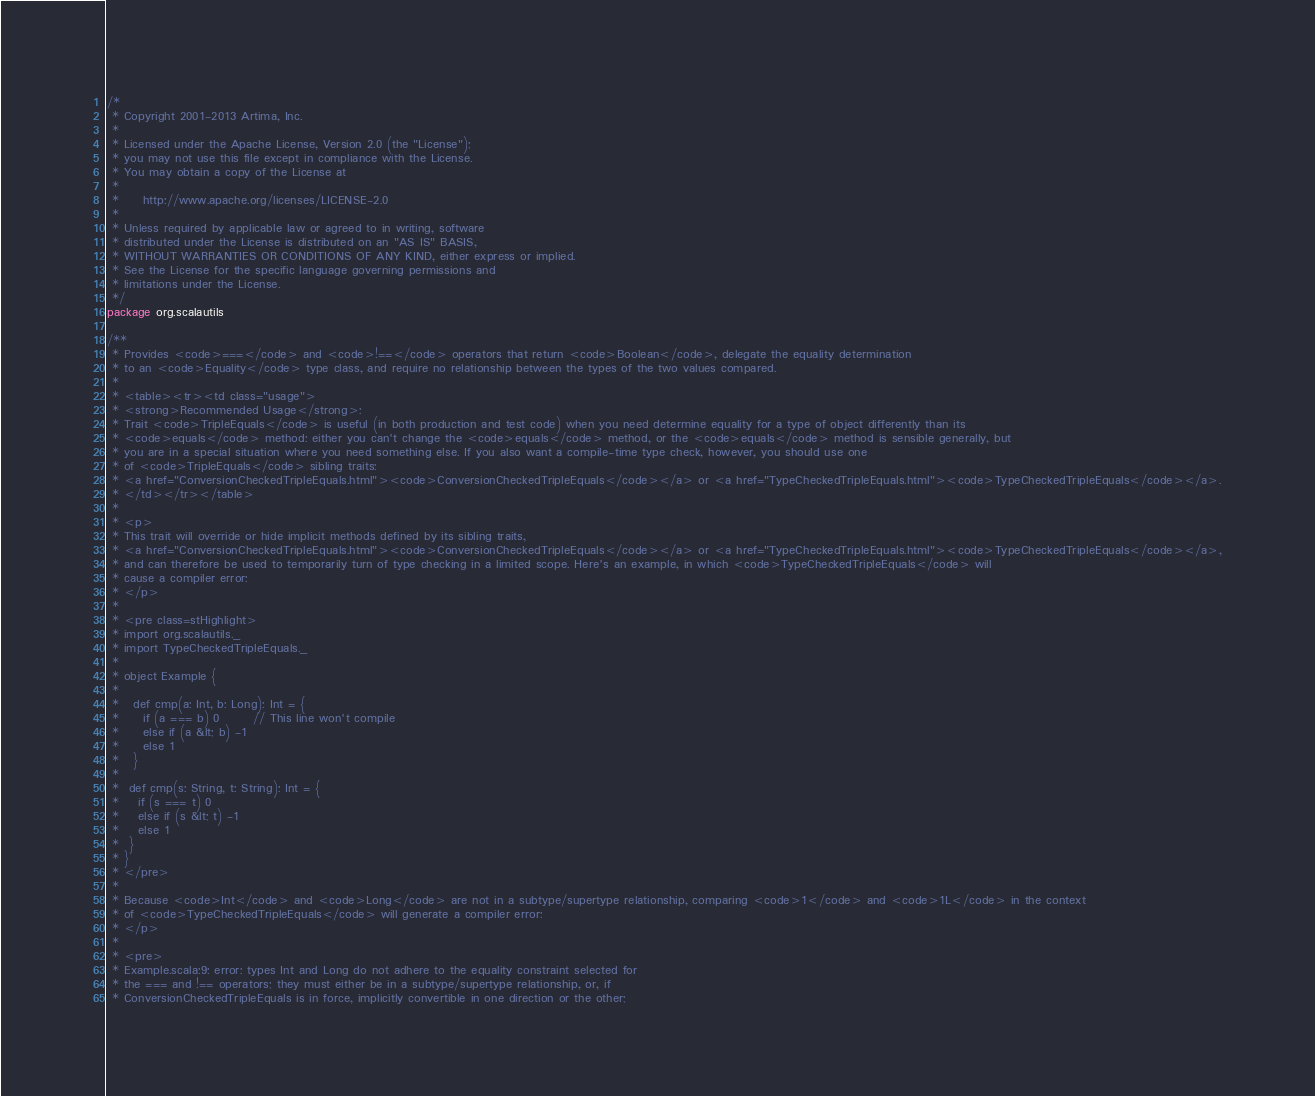Convert code to text. <code><loc_0><loc_0><loc_500><loc_500><_Scala_>/*
 * Copyright 2001-2013 Artima, Inc.
 *
 * Licensed under the Apache License, Version 2.0 (the "License");
 * you may not use this file except in compliance with the License.
 * You may obtain a copy of the License at
 *
 *     http://www.apache.org/licenses/LICENSE-2.0
 *
 * Unless required by applicable law or agreed to in writing, software
 * distributed under the License is distributed on an "AS IS" BASIS,
 * WITHOUT WARRANTIES OR CONDITIONS OF ANY KIND, either express or implied.
 * See the License for the specific language governing permissions and
 * limitations under the License.
 */
package org.scalautils

/**
 * Provides <code>===</code> and <code>!==</code> operators that return <code>Boolean</code>, delegate the equality determination
 * to an <code>Equality</code> type class, and require no relationship between the types of the two values compared. 
 * 
 * <table><tr><td class="usage">
 * <strong>Recommended Usage</strong>:
 * Trait <code>TripleEquals</code> is useful (in both production and test code) when you need determine equality for a type of object differently than its
 * <code>equals</code> method: either you can't change the <code>equals</code> method, or the <code>equals</code> method is sensible generally, but
 * you are in a special situation where you need something else. If you also want a compile-time type check, however, you should use one
 * of <code>TripleEquals</code> sibling traits: 
 * <a href="ConversionCheckedTripleEquals.html"><code>ConversionCheckedTripleEquals</code></a> or <a href="TypeCheckedTripleEquals.html"><code>TypeCheckedTripleEquals</code></a>.
 * </td></tr></table>
 *
 * <p>
 * This trait will override or hide implicit methods defined by its sibling traits,
 * <a href="ConversionCheckedTripleEquals.html"><code>ConversionCheckedTripleEquals</code></a> or <a href="TypeCheckedTripleEquals.html"><code>TypeCheckedTripleEquals</code></a>,
 * and can therefore be used to temporarily turn of type checking in a limited scope. Here's an example, in which <code>TypeCheckedTripleEquals</code> will
 * cause a compiler error:
 * </p>
 * 
 * <pre class=stHighlight>
 * import org.scalautils._
 * import TypeCheckedTripleEquals._
 *
 * object Example {
 *
 *   def cmp(a: Int, b: Long): Int = {
 *     if (a === b) 0       // This line won't compile
 *     else if (a &lt; b) -1
 *     else 1
 *   }
 *
 *  def cmp(s: String, t: String): Int = {
 *    if (s === t) 0
 *    else if (s &lt; t) -1
 *    else 1
 *  }
 * }
 * </pre>
 *
 * Because <code>Int</code> and <code>Long</code> are not in a subtype/supertype relationship, comparing <code>1</code> and <code>1L</code> in the context
 * of <code>TypeCheckedTripleEquals</code> will generate a compiler error:
 * </p>
 *
 * <pre>
 * Example.scala:9: error: types Int and Long do not adhere to the equality constraint selected for
 * the === and !== operators; they must either be in a subtype/supertype relationship, or, if
 * ConversionCheckedTripleEquals is in force, implicitly convertible in one direction or the other;</code> 